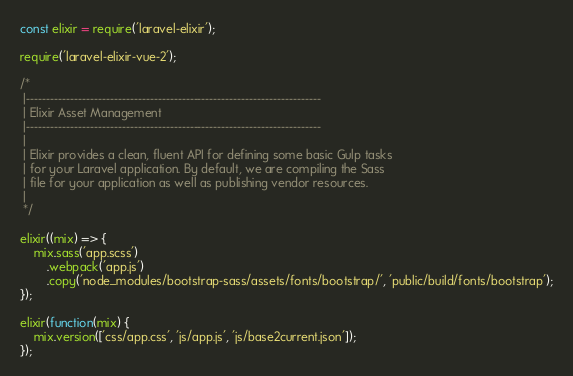Convert code to text. <code><loc_0><loc_0><loc_500><loc_500><_JavaScript_>const elixir = require('laravel-elixir');

require('laravel-elixir-vue-2');

/*
 |--------------------------------------------------------------------------
 | Elixir Asset Management
 |--------------------------------------------------------------------------
 |
 | Elixir provides a clean, fluent API for defining some basic Gulp tasks
 | for your Laravel application. By default, we are compiling the Sass
 | file for your application as well as publishing vendor resources.
 |
 */

elixir((mix) => {
	mix.sass('app.scss')
		.webpack('app.js')
		.copy('node_modules/bootstrap-sass/assets/fonts/bootstrap/', 'public/build/fonts/bootstrap');
});

elixir(function(mix) {
	mix.version(['css/app.css', 'js/app.js', 'js/base2current.json']);
});
</code> 